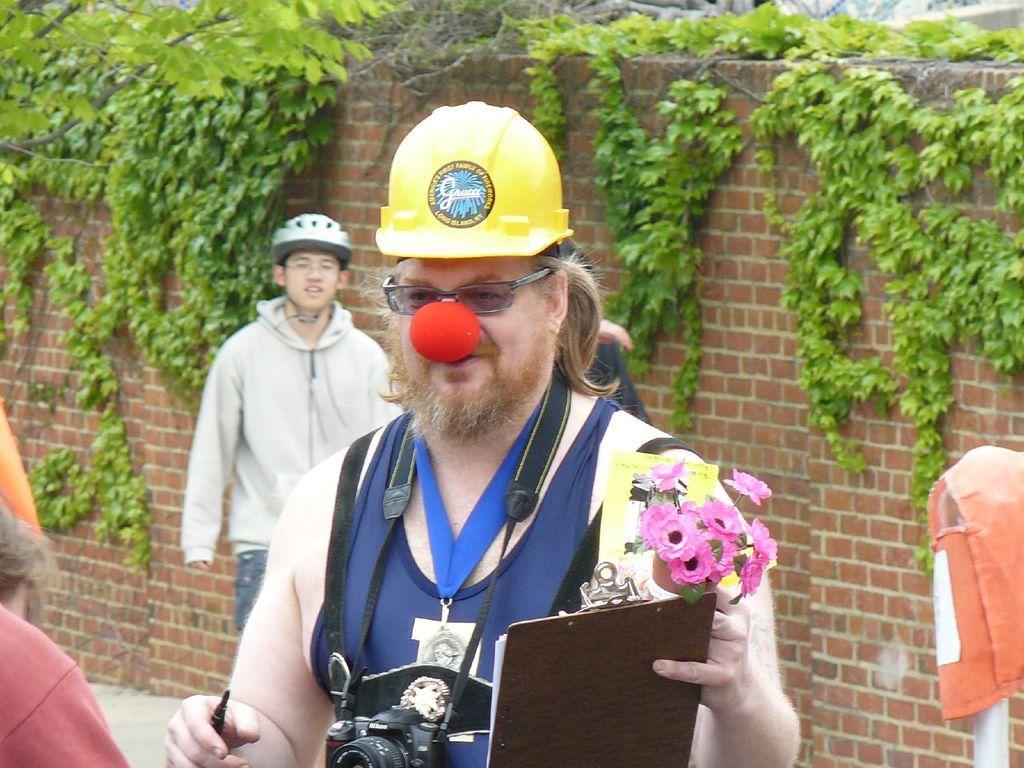Describe this image in one or two sentences. In the foreground of the image, there is a man wearing a helmet, camera and a ball to his nose is holding a pad, marker and flowers. On the left, it seems like people and on the right, there is a pole on which there is an orange color cloth. In the background, there is a man standing and also greenery on the wall. 